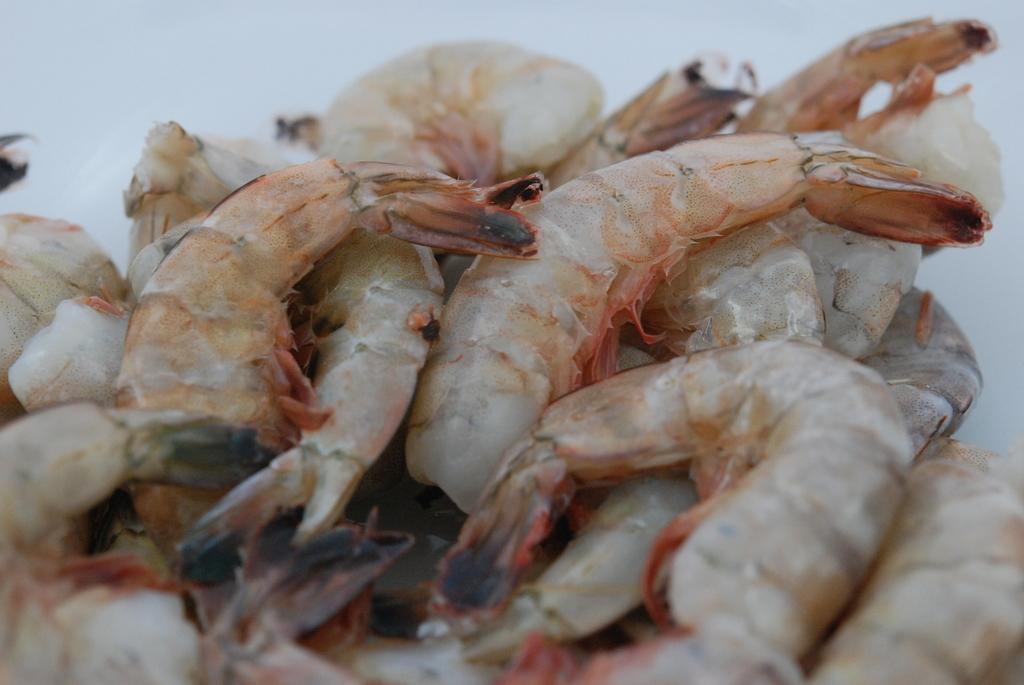Please provide a concise description of this image. In the middle of the image there are a few shrimps. 